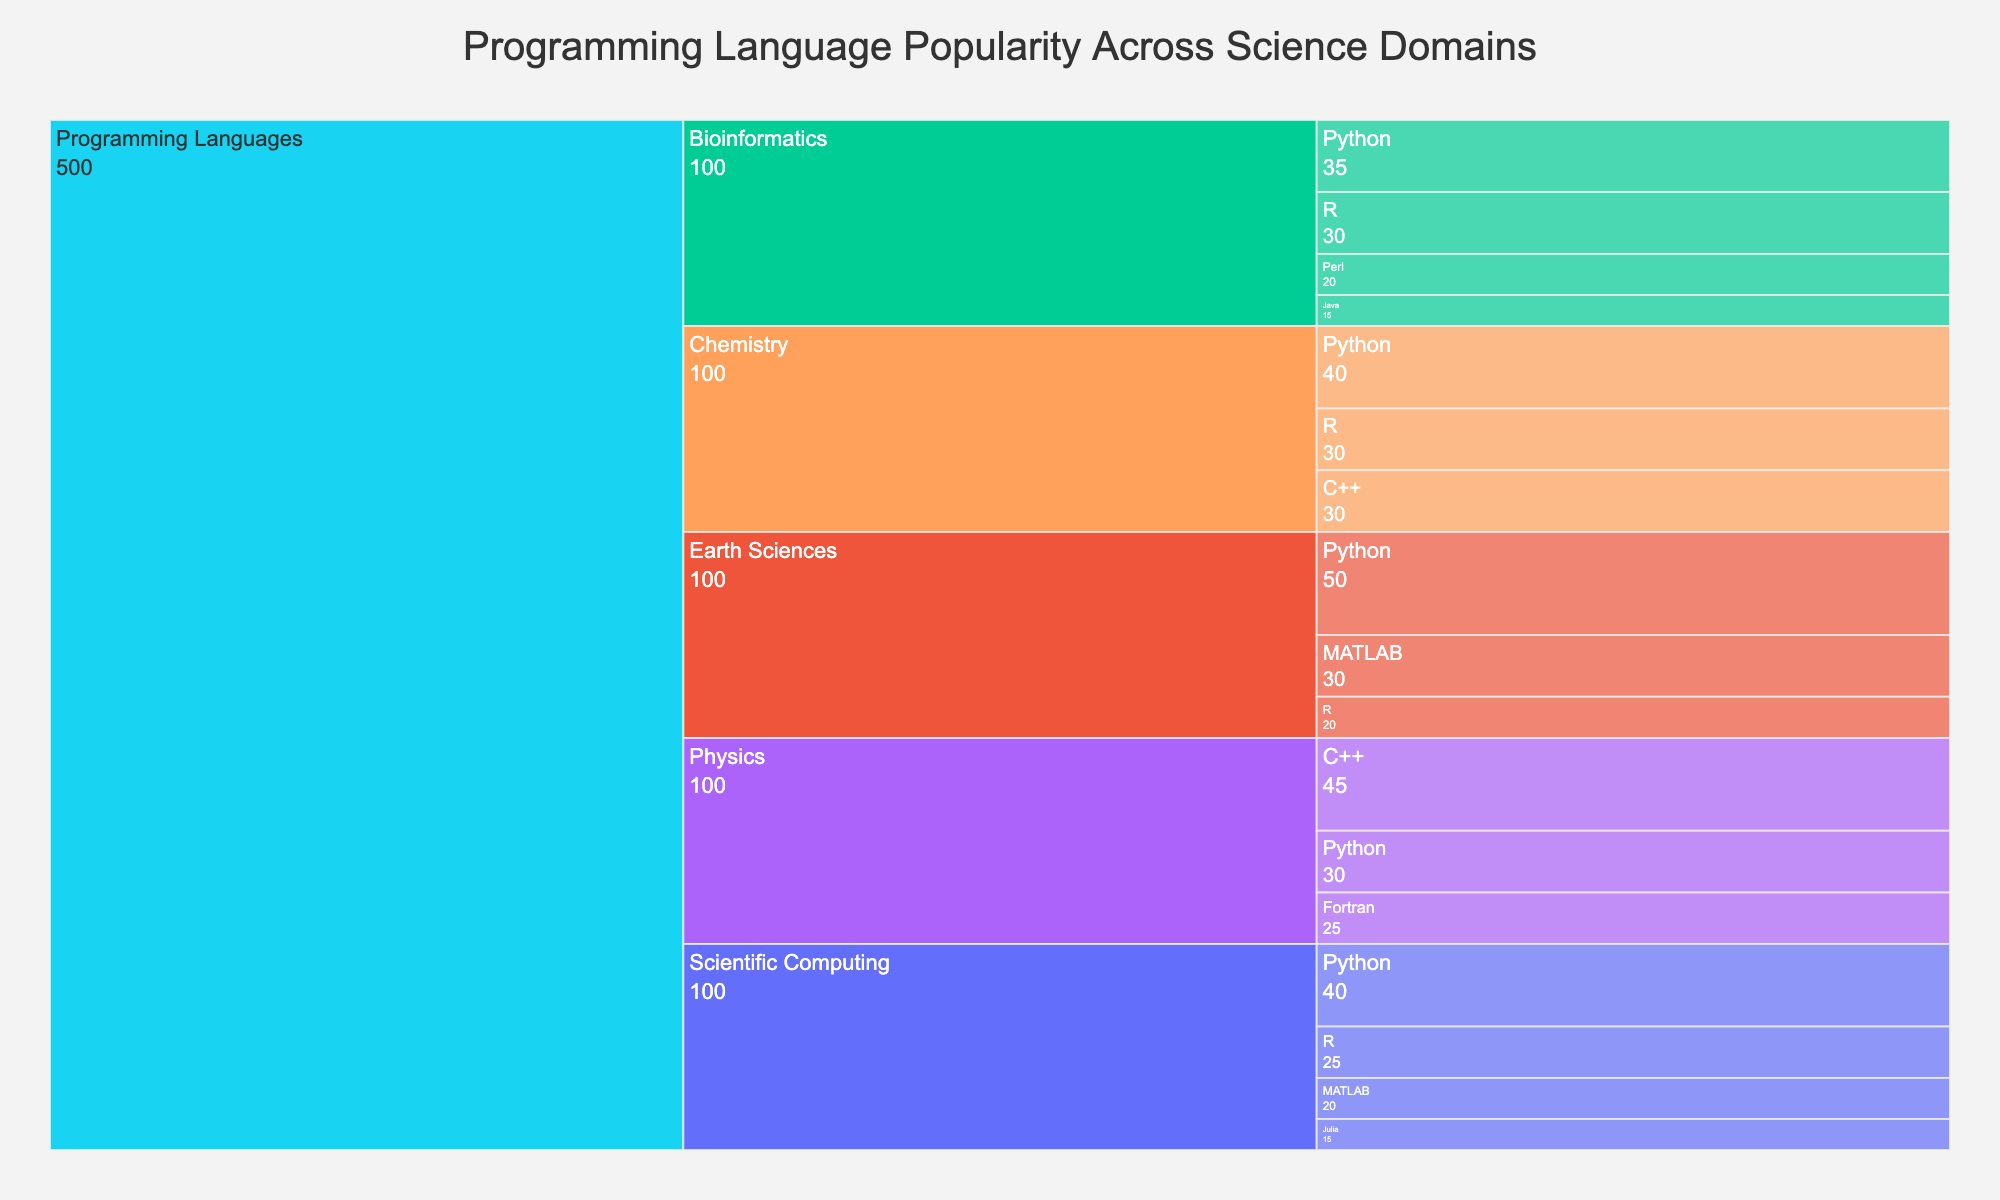what is the title of the figure? The title is usually placed at the top of the figure and describes the main topic or purpose of the visualization. In this case, the text at the top center reads "Programming Language Popularity Across Science Domains".
Answer: Programming Language Popularity Across Science Domains How many programming languages are shown in the category "Bioinformatics"? To determine this, we need to look at the breakdown beneath the "Bioinformatics" category label in the Icicle chart. There are four subcategories shown: Python, R, Perl, and Java.
Answer: 4 Which programming language is most popular in "Physics"? The value associated with each programming language within the "Physics" category determines its popularity. "C++" has the highest value at 45, compared to Python (30) and Fortran (25).
Answer: C++ What's the total value of Python across all categories? We need to sum up the values associated with Python in each category: 40 (Scientific Computing) + 35 (Bioinformatics) + 30 (Physics) + 40 (Chemistry) + 50 (Earth Sciences). Total = 40 + 35 + 30 + 40 + 50 = 195.
Answer: 195 Which category has the highest aggregated value, and what is that value? To find this, we sum the values of all subcategories within each category. 
- Scientific Computing: 40 (Python) + 25 (R) + 20 (MATLAB) + 15 (Julia) = 100
- Bioinformatics: 35 (Python) + 30 (R) + 20 (Perl) + 15 (Java) = 100
- Physics: 45 (C++) + 30 (Python) + 25 (Fortran) = 100
- Chemistry: 40 (Python) + 30 (C++) + 30 (R) = 100
- Earth Sciences: 50 (Python) + 30 (MATLAB) + 20 (R) = 100
All categories have an aggregated value of 100.
Answer: Each has 100 Which programming languages appear in more than one category? We need to check which programming languages are repeated across different categories in the Icicle chart. Python is present in all categories. R appears in Scientific Computing, Bioinformatics, Chemistry, and Earth Sciences. C++ appears in Physics and Chemistry.
Answer: Python, R, C++ Is "MATLAB" more popular in "Scientific Computing" or "Earth Sciences"? We compare the values for MATLAB in the two categories. In "Scientific Computing", MATLAB has a value of 20. In "Earth Sciences", MATLAB has a value of 30. Thus, MATLAB is more popular in Earth Sciences.
Answer: Earth Sciences Among the languages listed in "Scientific Computing", which one is the least popular? In the Scientific Computing category, we compare the popularity values: Python (40), R (25), MATLAB (20), and Julia (15). Julia has the lowest value.
Answer: Julia 